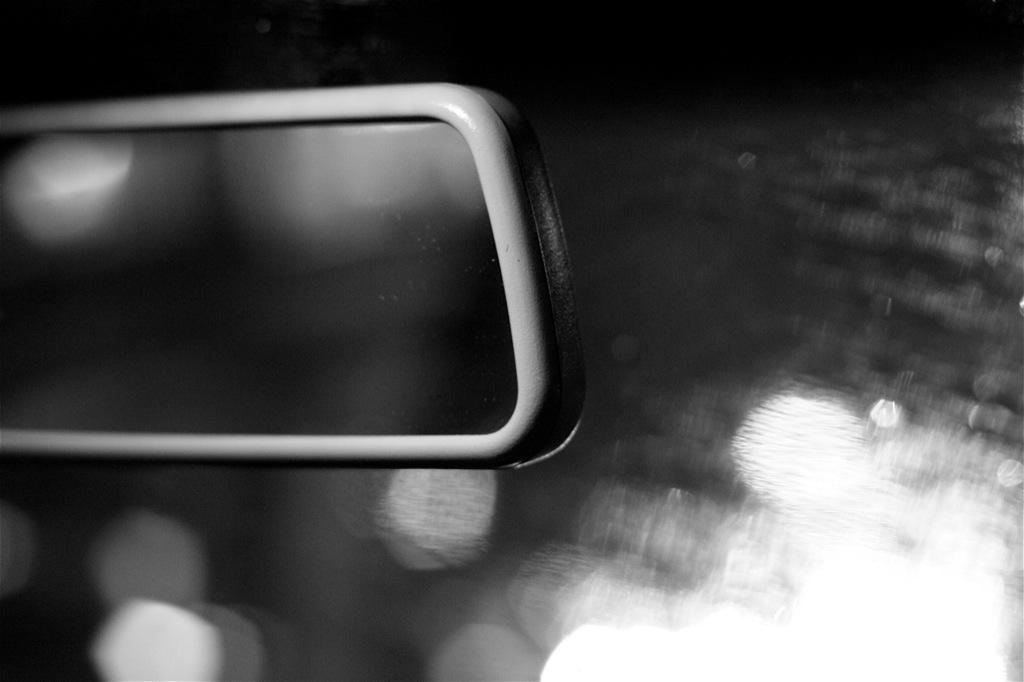What is the overall appearance of the image? The image is blurred and black and white. Can you describe the object on the left side of the image? Unfortunately, due to the blurred nature of the image, it is difficult to provide a detailed description of the object on the left side. What letter is written on the chalkboard in the image? There is no chalkboard or letter present in the image. What type of school is depicted in the image? There is no school depicted in the image. 